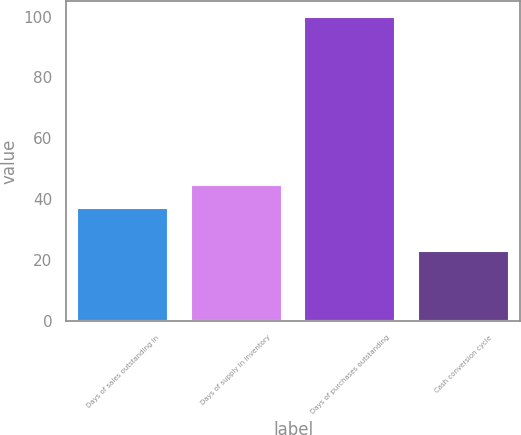Convert chart to OTSL. <chart><loc_0><loc_0><loc_500><loc_500><bar_chart><fcel>Days of sales outstanding in<fcel>Days of supply in inventory<fcel>Days of purchases outstanding<fcel>Cash conversion cycle<nl><fcel>37<fcel>44.7<fcel>100<fcel>23<nl></chart> 